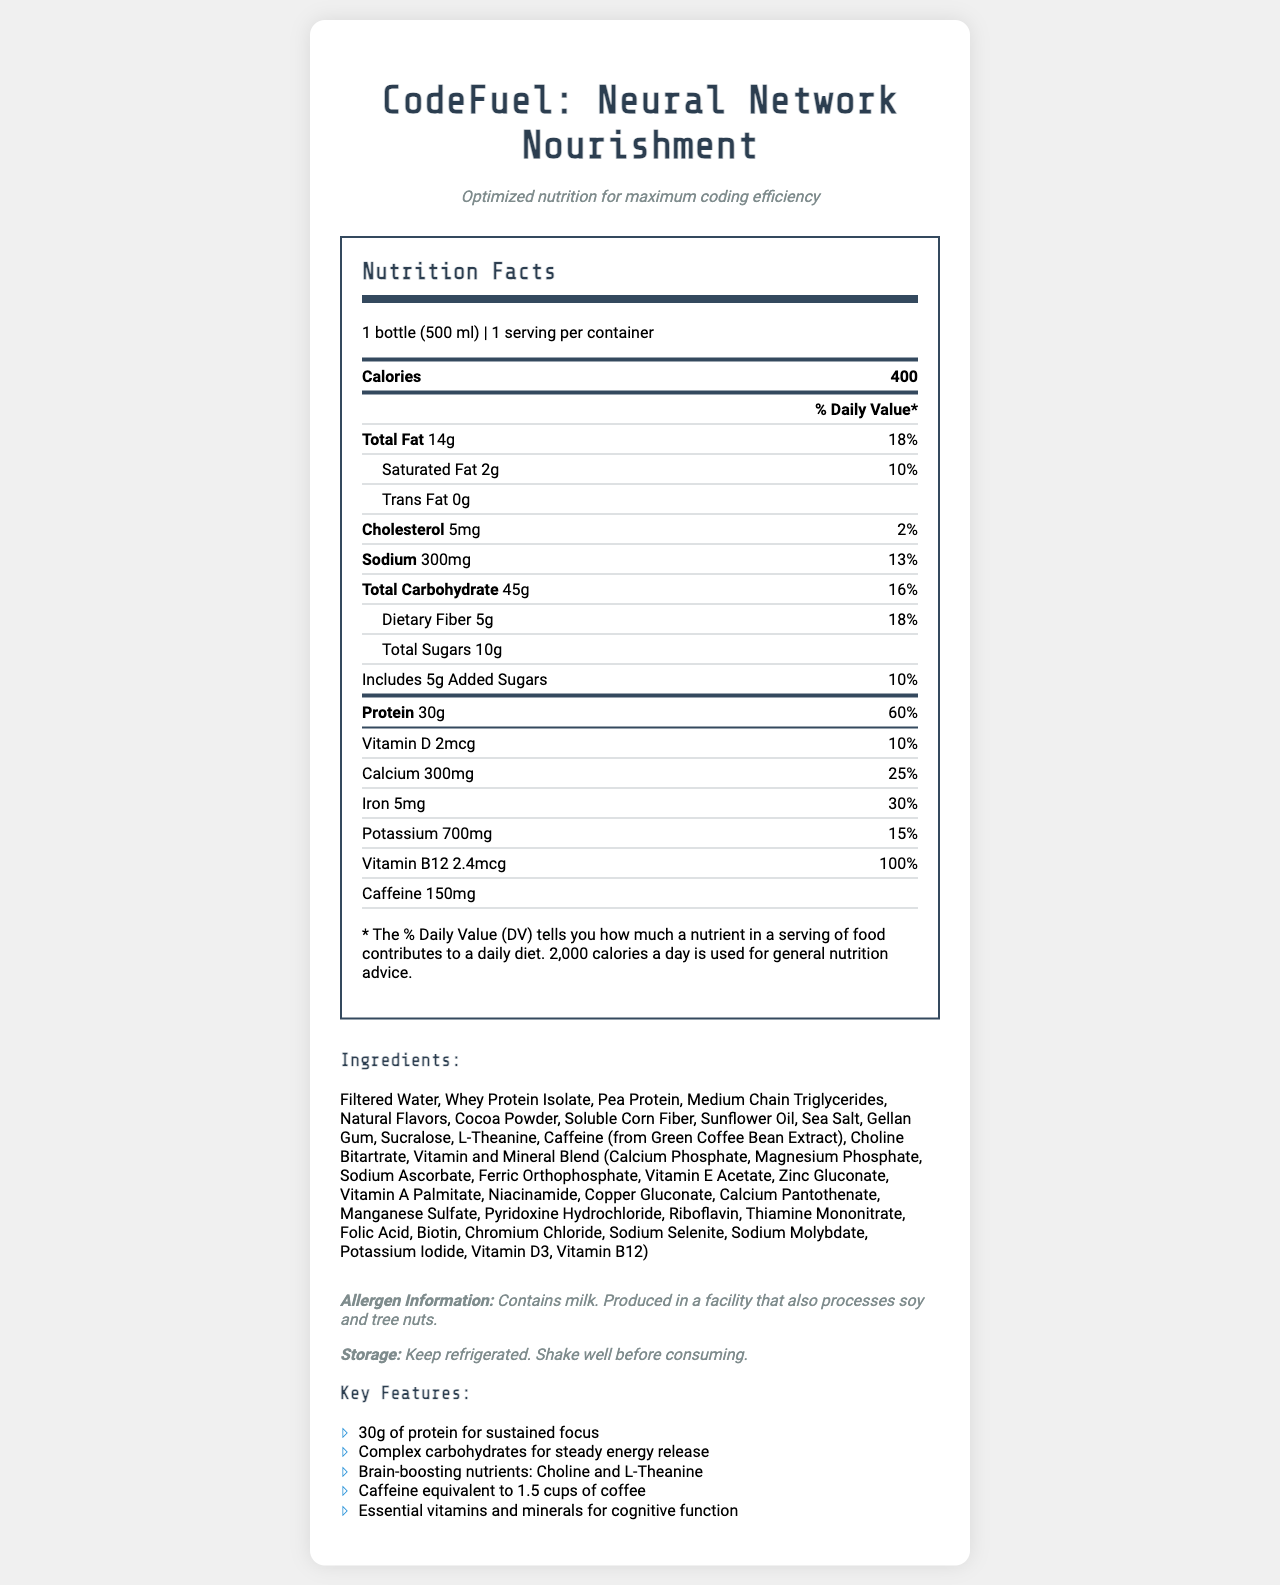what is the serving size of the product? The serving size is mentioned at the top of the nutrition facts under the "Nutrition Facts" header.
Answer: 1 bottle (500 ml) how many calories are in one serving of CodeFuel? The number of calories per serving is listed right below the serving size and servings per container.
Answer: 400 what is the total fat content and its % Daily Value? The total fat content and its % Daily Value are listed in the nutrition label under "Total Fat."
Answer: 14g, 18% how much protein does CodeFuel contain per serving? The protein content is specified in the nutrition facts as 30g, along with 60% of the daily value.
Answer: 30g does CodeFuel contain any trans fat? The trans fat content is listed as 0g under the total fat section in the nutrition label.
Answer: No what is the % Daily Value of calcium in CodeFuel? The % Daily Value of calcium is listed under the daily values section, showing 25%.
Answer: 25% how many grams of dietary fiber are in one serving? The amount of dietary fiber is shown in the nutrition label as 5g.
Answer: 5g does the product contain caffeine? Caffeine content is listed as 150mg in the nutrition label.
Answer: Yes is the product suitable for someone with a soy allergy? The product is produced in a facility that also processes soy and tree nuts, as mentioned in the allergen information.
Answer: No, it might not be which of the following nutrients is included in the vitamin and mineral blend? A. Vitamin C B. Vitamin E C. Folic Acid D. Vitamin K The list of ingredients includes Folic Acid as part of the vitamin and mineral blend.
Answer: C. Folic Acid what is the tagline of the product? A. Fuel for Coders B. Optimal Nutrition C. Sustained Energy D. Optimized nutrition for maximum coding efficiency The tagline is mentioned at the top of the document right below the product name.
Answer: D which ingredient is NOT listed in CodeFuel? A. Sea Salt B. Pea Protein C. Honey D. Gellan Gum The ingredient list does not include Honey, but it includes Sea Salt, Pea Protein, and Gellan Gum.
Answer: C. Honey is the % Daily Value of Sodium in CodeFuel greater than 10%? The % Daily Value of Sodium is listed as 13%.
Answer: Yes summarize the main idea of the document. The document gives a comprehensive overview of CodeFuel’s nutritional benefits, ingredients, and usage instructions targeted at individuals seeking optimal nutrition during long coding sessions.
Answer: The document provides the nutrition facts and key features of the protein-packed meal replacement shake named "CodeFuel: Neural Network Nourishment." It highlights its 30g protein content, essential vitamins, minerals, and caffeine for brain-boosting and sustained focus, making it suitable for long coding sessions. Additionally, allergen information, storage instructions, and ingredients are provided. what is the total amount of cholesterol in a week's worth of servings (assuming one serving per day)? The document does not provide the number of days in a week or servings per day assumption explicitly, so this calculation cannot be determined with certainty based solely on the visual information provided.
Answer: Cannot be determined 